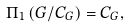Convert formula to latex. <formula><loc_0><loc_0><loc_500><loc_500>\Pi _ { 1 } \left ( G / C _ { G } \right ) = C _ { G } ,</formula> 